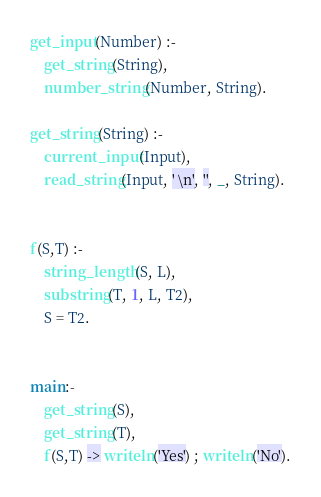<code> <loc_0><loc_0><loc_500><loc_500><_Prolog_>get_input(Number) :-
    get_string(String),
    number_string(Number, String).

get_string(String) :-
    current_input(Input),
    read_string(Input, ' \n', '', _, String).


f(S,T) :- 
    string_length(S, L),
    substring(T, 1, L, T2),
    S = T2.


main:-
    get_string(S),
    get_string(T),
    f(S,T) -> writeln('Yes') ; writeln('No').
</code> 